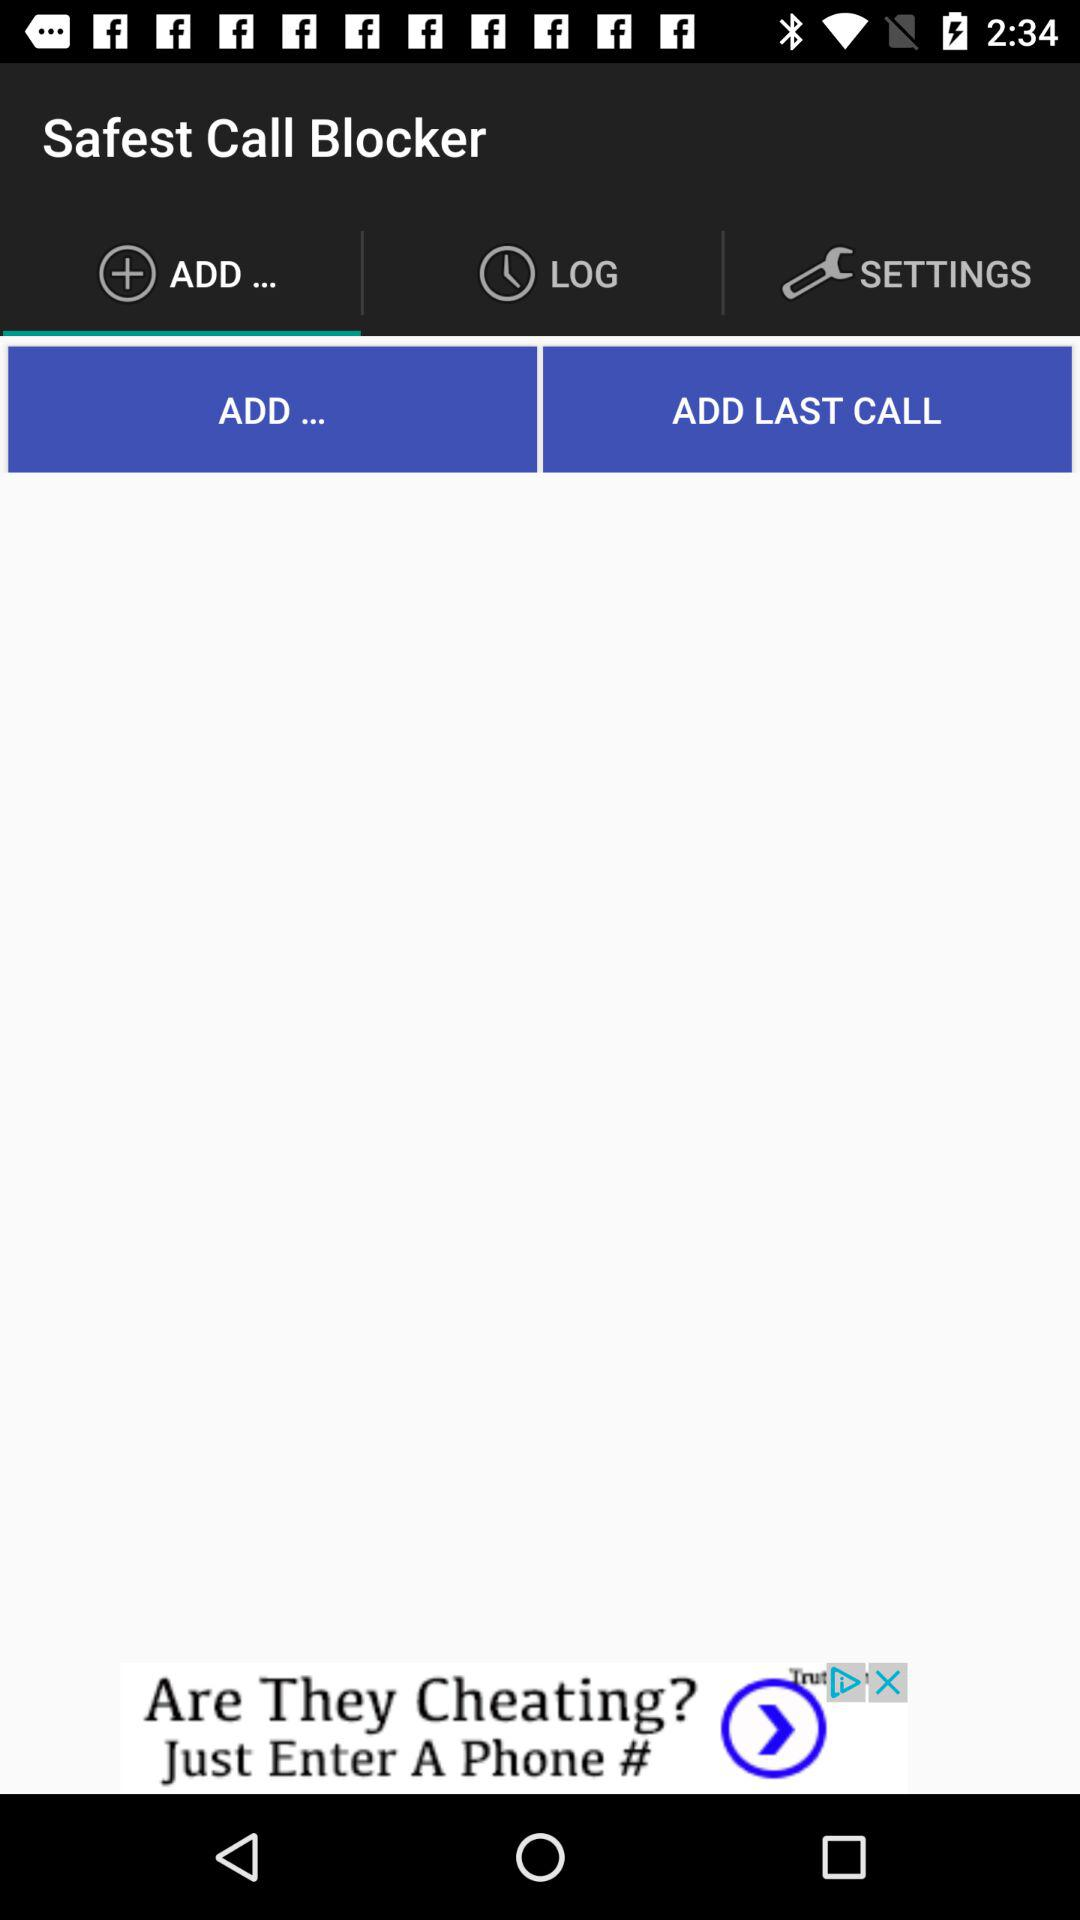How many notifications are there in "SETTINGS"?
When the provided information is insufficient, respond with <no answer>. <no answer> 